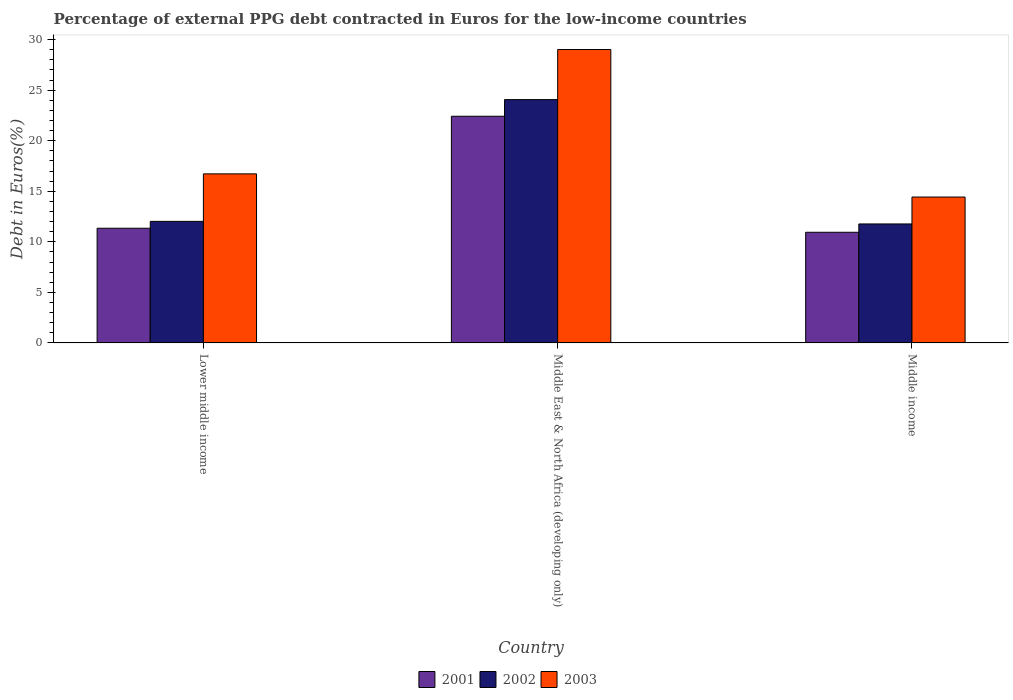How many groups of bars are there?
Give a very brief answer. 3. Are the number of bars per tick equal to the number of legend labels?
Keep it short and to the point. Yes. Are the number of bars on each tick of the X-axis equal?
Your answer should be very brief. Yes. What is the label of the 1st group of bars from the left?
Give a very brief answer. Lower middle income. In how many cases, is the number of bars for a given country not equal to the number of legend labels?
Keep it short and to the point. 0. What is the percentage of external PPG debt contracted in Euros in 2001 in Middle income?
Offer a very short reply. 10.94. Across all countries, what is the maximum percentage of external PPG debt contracted in Euros in 2002?
Give a very brief answer. 24.06. Across all countries, what is the minimum percentage of external PPG debt contracted in Euros in 2001?
Your response must be concise. 10.94. In which country was the percentage of external PPG debt contracted in Euros in 2002 maximum?
Your response must be concise. Middle East & North Africa (developing only). What is the total percentage of external PPG debt contracted in Euros in 2002 in the graph?
Your answer should be very brief. 47.85. What is the difference between the percentage of external PPG debt contracted in Euros in 2001 in Middle East & North Africa (developing only) and that in Middle income?
Keep it short and to the point. 11.47. What is the difference between the percentage of external PPG debt contracted in Euros in 2003 in Lower middle income and the percentage of external PPG debt contracted in Euros in 2002 in Middle East & North Africa (developing only)?
Your answer should be very brief. -7.34. What is the average percentage of external PPG debt contracted in Euros in 2003 per country?
Ensure brevity in your answer.  20.05. What is the difference between the percentage of external PPG debt contracted in Euros of/in 2003 and percentage of external PPG debt contracted in Euros of/in 2002 in Middle East & North Africa (developing only)?
Your answer should be compact. 4.95. In how many countries, is the percentage of external PPG debt contracted in Euros in 2001 greater than 13 %?
Your response must be concise. 1. What is the ratio of the percentage of external PPG debt contracted in Euros in 2001 in Middle East & North Africa (developing only) to that in Middle income?
Provide a short and direct response. 2.05. Is the difference between the percentage of external PPG debt contracted in Euros in 2003 in Middle East & North Africa (developing only) and Middle income greater than the difference between the percentage of external PPG debt contracted in Euros in 2002 in Middle East & North Africa (developing only) and Middle income?
Make the answer very short. Yes. What is the difference between the highest and the second highest percentage of external PPG debt contracted in Euros in 2002?
Ensure brevity in your answer.  12.3. What is the difference between the highest and the lowest percentage of external PPG debt contracted in Euros in 2003?
Offer a terse response. 14.59. Is the sum of the percentage of external PPG debt contracted in Euros in 2001 in Lower middle income and Middle income greater than the maximum percentage of external PPG debt contracted in Euros in 2003 across all countries?
Provide a short and direct response. No. What does the 3rd bar from the left in Lower middle income represents?
Your answer should be very brief. 2003. Is it the case that in every country, the sum of the percentage of external PPG debt contracted in Euros in 2002 and percentage of external PPG debt contracted in Euros in 2001 is greater than the percentage of external PPG debt contracted in Euros in 2003?
Your answer should be very brief. Yes. How many bars are there?
Offer a terse response. 9. Are all the bars in the graph horizontal?
Your answer should be very brief. No. How many countries are there in the graph?
Make the answer very short. 3. Does the graph contain grids?
Your response must be concise. No. Where does the legend appear in the graph?
Provide a short and direct response. Bottom center. How many legend labels are there?
Provide a succinct answer. 3. What is the title of the graph?
Ensure brevity in your answer.  Percentage of external PPG debt contracted in Euros for the low-income countries. Does "1964" appear as one of the legend labels in the graph?
Make the answer very short. No. What is the label or title of the X-axis?
Offer a very short reply. Country. What is the label or title of the Y-axis?
Provide a succinct answer. Debt in Euros(%). What is the Debt in Euros(%) in 2001 in Lower middle income?
Make the answer very short. 11.34. What is the Debt in Euros(%) in 2002 in Lower middle income?
Ensure brevity in your answer.  12.02. What is the Debt in Euros(%) in 2003 in Lower middle income?
Keep it short and to the point. 16.72. What is the Debt in Euros(%) in 2001 in Middle East & North Africa (developing only)?
Your response must be concise. 22.42. What is the Debt in Euros(%) of 2002 in Middle East & North Africa (developing only)?
Provide a short and direct response. 24.06. What is the Debt in Euros(%) in 2003 in Middle East & North Africa (developing only)?
Give a very brief answer. 29.01. What is the Debt in Euros(%) of 2001 in Middle income?
Your answer should be very brief. 10.94. What is the Debt in Euros(%) in 2002 in Middle income?
Provide a succinct answer. 11.77. What is the Debt in Euros(%) of 2003 in Middle income?
Make the answer very short. 14.43. Across all countries, what is the maximum Debt in Euros(%) of 2001?
Offer a terse response. 22.42. Across all countries, what is the maximum Debt in Euros(%) in 2002?
Ensure brevity in your answer.  24.06. Across all countries, what is the maximum Debt in Euros(%) in 2003?
Offer a very short reply. 29.01. Across all countries, what is the minimum Debt in Euros(%) in 2001?
Ensure brevity in your answer.  10.94. Across all countries, what is the minimum Debt in Euros(%) in 2002?
Your response must be concise. 11.77. Across all countries, what is the minimum Debt in Euros(%) in 2003?
Keep it short and to the point. 14.43. What is the total Debt in Euros(%) in 2001 in the graph?
Provide a succinct answer. 44.7. What is the total Debt in Euros(%) in 2002 in the graph?
Offer a terse response. 47.85. What is the total Debt in Euros(%) in 2003 in the graph?
Offer a terse response. 60.16. What is the difference between the Debt in Euros(%) of 2001 in Lower middle income and that in Middle East & North Africa (developing only)?
Make the answer very short. -11.07. What is the difference between the Debt in Euros(%) in 2002 in Lower middle income and that in Middle East & North Africa (developing only)?
Make the answer very short. -12.04. What is the difference between the Debt in Euros(%) of 2003 in Lower middle income and that in Middle East & North Africa (developing only)?
Your answer should be compact. -12.3. What is the difference between the Debt in Euros(%) in 2001 in Lower middle income and that in Middle income?
Make the answer very short. 0.4. What is the difference between the Debt in Euros(%) in 2002 in Lower middle income and that in Middle income?
Keep it short and to the point. 0.25. What is the difference between the Debt in Euros(%) of 2003 in Lower middle income and that in Middle income?
Offer a terse response. 2.29. What is the difference between the Debt in Euros(%) in 2001 in Middle East & North Africa (developing only) and that in Middle income?
Offer a very short reply. 11.47. What is the difference between the Debt in Euros(%) of 2002 in Middle East & North Africa (developing only) and that in Middle income?
Provide a short and direct response. 12.3. What is the difference between the Debt in Euros(%) of 2003 in Middle East & North Africa (developing only) and that in Middle income?
Offer a terse response. 14.59. What is the difference between the Debt in Euros(%) in 2001 in Lower middle income and the Debt in Euros(%) in 2002 in Middle East & North Africa (developing only)?
Your answer should be very brief. -12.72. What is the difference between the Debt in Euros(%) of 2001 in Lower middle income and the Debt in Euros(%) of 2003 in Middle East & North Africa (developing only)?
Provide a succinct answer. -17.67. What is the difference between the Debt in Euros(%) in 2002 in Lower middle income and the Debt in Euros(%) in 2003 in Middle East & North Africa (developing only)?
Provide a succinct answer. -16.99. What is the difference between the Debt in Euros(%) of 2001 in Lower middle income and the Debt in Euros(%) of 2002 in Middle income?
Your answer should be very brief. -0.43. What is the difference between the Debt in Euros(%) in 2001 in Lower middle income and the Debt in Euros(%) in 2003 in Middle income?
Your answer should be very brief. -3.08. What is the difference between the Debt in Euros(%) in 2002 in Lower middle income and the Debt in Euros(%) in 2003 in Middle income?
Keep it short and to the point. -2.41. What is the difference between the Debt in Euros(%) of 2001 in Middle East & North Africa (developing only) and the Debt in Euros(%) of 2002 in Middle income?
Your answer should be compact. 10.65. What is the difference between the Debt in Euros(%) in 2001 in Middle East & North Africa (developing only) and the Debt in Euros(%) in 2003 in Middle income?
Your answer should be compact. 7.99. What is the difference between the Debt in Euros(%) of 2002 in Middle East & North Africa (developing only) and the Debt in Euros(%) of 2003 in Middle income?
Offer a very short reply. 9.64. What is the average Debt in Euros(%) of 2001 per country?
Offer a very short reply. 14.9. What is the average Debt in Euros(%) of 2002 per country?
Make the answer very short. 15.95. What is the average Debt in Euros(%) of 2003 per country?
Your answer should be compact. 20.05. What is the difference between the Debt in Euros(%) in 2001 and Debt in Euros(%) in 2002 in Lower middle income?
Keep it short and to the point. -0.68. What is the difference between the Debt in Euros(%) of 2001 and Debt in Euros(%) of 2003 in Lower middle income?
Give a very brief answer. -5.38. What is the difference between the Debt in Euros(%) in 2002 and Debt in Euros(%) in 2003 in Lower middle income?
Provide a succinct answer. -4.7. What is the difference between the Debt in Euros(%) in 2001 and Debt in Euros(%) in 2002 in Middle East & North Africa (developing only)?
Your answer should be compact. -1.65. What is the difference between the Debt in Euros(%) of 2001 and Debt in Euros(%) of 2003 in Middle East & North Africa (developing only)?
Keep it short and to the point. -6.6. What is the difference between the Debt in Euros(%) of 2002 and Debt in Euros(%) of 2003 in Middle East & North Africa (developing only)?
Your response must be concise. -4.95. What is the difference between the Debt in Euros(%) in 2001 and Debt in Euros(%) in 2002 in Middle income?
Offer a terse response. -0.82. What is the difference between the Debt in Euros(%) of 2001 and Debt in Euros(%) of 2003 in Middle income?
Offer a terse response. -3.48. What is the difference between the Debt in Euros(%) in 2002 and Debt in Euros(%) in 2003 in Middle income?
Provide a succinct answer. -2.66. What is the ratio of the Debt in Euros(%) of 2001 in Lower middle income to that in Middle East & North Africa (developing only)?
Provide a short and direct response. 0.51. What is the ratio of the Debt in Euros(%) of 2002 in Lower middle income to that in Middle East & North Africa (developing only)?
Offer a very short reply. 0.5. What is the ratio of the Debt in Euros(%) of 2003 in Lower middle income to that in Middle East & North Africa (developing only)?
Provide a short and direct response. 0.58. What is the ratio of the Debt in Euros(%) of 2001 in Lower middle income to that in Middle income?
Give a very brief answer. 1.04. What is the ratio of the Debt in Euros(%) in 2002 in Lower middle income to that in Middle income?
Ensure brevity in your answer.  1.02. What is the ratio of the Debt in Euros(%) of 2003 in Lower middle income to that in Middle income?
Your answer should be compact. 1.16. What is the ratio of the Debt in Euros(%) of 2001 in Middle East & North Africa (developing only) to that in Middle income?
Your answer should be very brief. 2.05. What is the ratio of the Debt in Euros(%) in 2002 in Middle East & North Africa (developing only) to that in Middle income?
Ensure brevity in your answer.  2.04. What is the ratio of the Debt in Euros(%) in 2003 in Middle East & North Africa (developing only) to that in Middle income?
Offer a terse response. 2.01. What is the difference between the highest and the second highest Debt in Euros(%) in 2001?
Provide a succinct answer. 11.07. What is the difference between the highest and the second highest Debt in Euros(%) of 2002?
Your answer should be very brief. 12.04. What is the difference between the highest and the second highest Debt in Euros(%) of 2003?
Your response must be concise. 12.3. What is the difference between the highest and the lowest Debt in Euros(%) of 2001?
Your answer should be very brief. 11.47. What is the difference between the highest and the lowest Debt in Euros(%) in 2002?
Your response must be concise. 12.3. What is the difference between the highest and the lowest Debt in Euros(%) of 2003?
Keep it short and to the point. 14.59. 